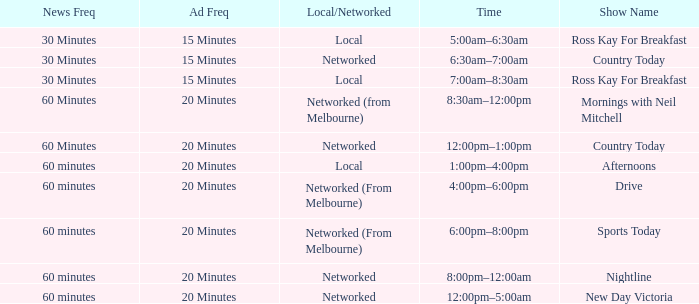What Time has a Show Name of mornings with neil mitchell? 8:30am–12:00pm. 